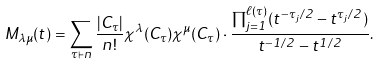Convert formula to latex. <formula><loc_0><loc_0><loc_500><loc_500>M _ { \lambda \mu } ( t ) = \sum _ { \tau \vdash n } \frac { | C _ { \tau } | } { n ! } \chi ^ { \lambda } ( C _ { \tau } ) \chi ^ { \mu } ( C _ { \tau } ) \cdot \frac { \prod _ { j = 1 } ^ { \ell ( \tau ) } ( t ^ { - \tau _ { j } / 2 } - t ^ { \tau _ { j } / 2 } ) } { t ^ { - 1 / 2 } - t ^ { 1 / 2 } } .</formula> 